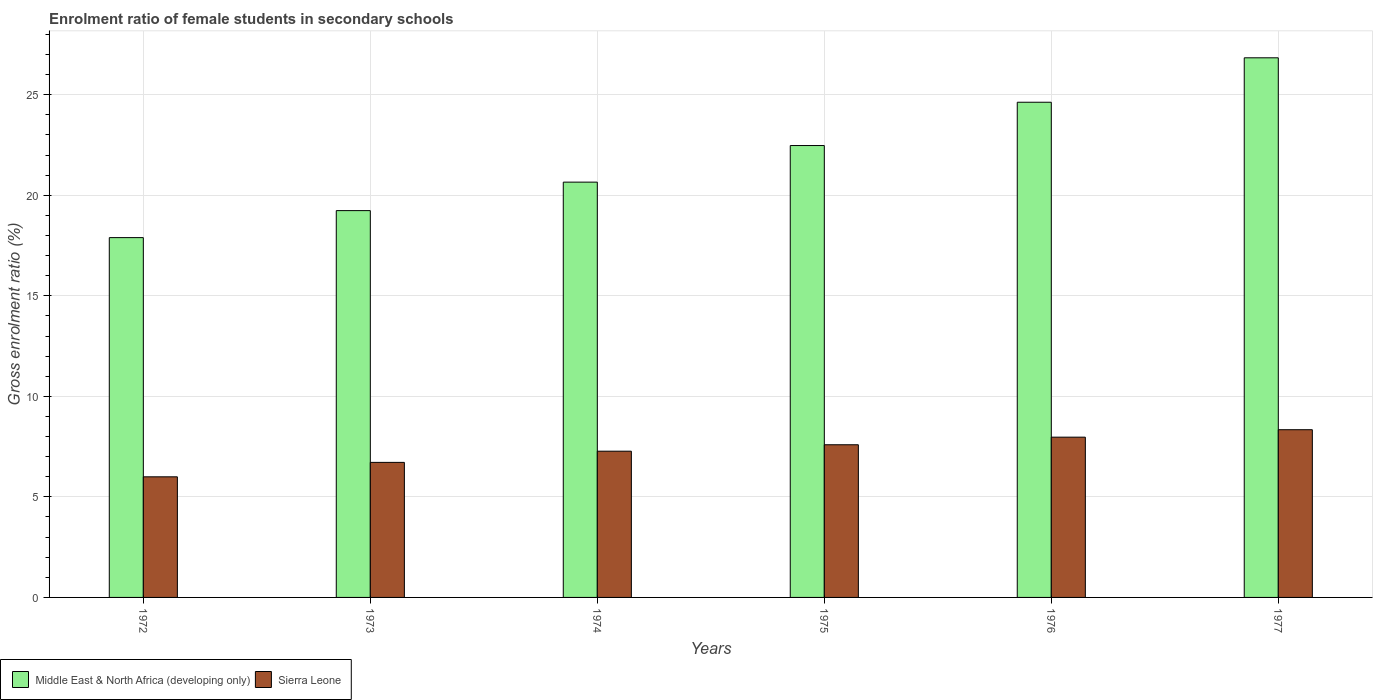How many different coloured bars are there?
Give a very brief answer. 2. How many groups of bars are there?
Your response must be concise. 6. How many bars are there on the 1st tick from the left?
Your response must be concise. 2. What is the label of the 1st group of bars from the left?
Make the answer very short. 1972. In how many cases, is the number of bars for a given year not equal to the number of legend labels?
Keep it short and to the point. 0. What is the enrolment ratio of female students in secondary schools in Middle East & North Africa (developing only) in 1975?
Provide a short and direct response. 22.47. Across all years, what is the maximum enrolment ratio of female students in secondary schools in Middle East & North Africa (developing only)?
Your response must be concise. 26.83. Across all years, what is the minimum enrolment ratio of female students in secondary schools in Sierra Leone?
Provide a succinct answer. 6. What is the total enrolment ratio of female students in secondary schools in Sierra Leone in the graph?
Give a very brief answer. 43.89. What is the difference between the enrolment ratio of female students in secondary schools in Middle East & North Africa (developing only) in 1974 and that in 1977?
Give a very brief answer. -6.18. What is the difference between the enrolment ratio of female students in secondary schools in Sierra Leone in 1977 and the enrolment ratio of female students in secondary schools in Middle East & North Africa (developing only) in 1976?
Your answer should be compact. -16.28. What is the average enrolment ratio of female students in secondary schools in Middle East & North Africa (developing only) per year?
Provide a short and direct response. 21.95. In the year 1974, what is the difference between the enrolment ratio of female students in secondary schools in Middle East & North Africa (developing only) and enrolment ratio of female students in secondary schools in Sierra Leone?
Provide a short and direct response. 13.38. What is the ratio of the enrolment ratio of female students in secondary schools in Middle East & North Africa (developing only) in 1974 to that in 1975?
Provide a short and direct response. 0.92. Is the enrolment ratio of female students in secondary schools in Sierra Leone in 1972 less than that in 1977?
Offer a terse response. Yes. Is the difference between the enrolment ratio of female students in secondary schools in Middle East & North Africa (developing only) in 1973 and 1977 greater than the difference between the enrolment ratio of female students in secondary schools in Sierra Leone in 1973 and 1977?
Provide a succinct answer. No. What is the difference between the highest and the second highest enrolment ratio of female students in secondary schools in Sierra Leone?
Provide a succinct answer. 0.37. What is the difference between the highest and the lowest enrolment ratio of female students in secondary schools in Sierra Leone?
Provide a short and direct response. 2.34. Is the sum of the enrolment ratio of female students in secondary schools in Sierra Leone in 1972 and 1975 greater than the maximum enrolment ratio of female students in secondary schools in Middle East & North Africa (developing only) across all years?
Make the answer very short. No. What does the 2nd bar from the left in 1975 represents?
Your answer should be very brief. Sierra Leone. What does the 2nd bar from the right in 1972 represents?
Your answer should be very brief. Middle East & North Africa (developing only). How many bars are there?
Your response must be concise. 12. Are all the bars in the graph horizontal?
Make the answer very short. No. Does the graph contain any zero values?
Make the answer very short. No. Where does the legend appear in the graph?
Give a very brief answer. Bottom left. What is the title of the graph?
Your response must be concise. Enrolment ratio of female students in secondary schools. Does "Uruguay" appear as one of the legend labels in the graph?
Give a very brief answer. No. What is the label or title of the X-axis?
Your answer should be very brief. Years. What is the Gross enrolment ratio (%) of Middle East & North Africa (developing only) in 1972?
Offer a terse response. 17.89. What is the Gross enrolment ratio (%) in Sierra Leone in 1972?
Give a very brief answer. 6. What is the Gross enrolment ratio (%) of Middle East & North Africa (developing only) in 1973?
Give a very brief answer. 19.24. What is the Gross enrolment ratio (%) in Sierra Leone in 1973?
Offer a very short reply. 6.72. What is the Gross enrolment ratio (%) of Middle East & North Africa (developing only) in 1974?
Your response must be concise. 20.65. What is the Gross enrolment ratio (%) of Sierra Leone in 1974?
Your answer should be very brief. 7.27. What is the Gross enrolment ratio (%) of Middle East & North Africa (developing only) in 1975?
Offer a very short reply. 22.47. What is the Gross enrolment ratio (%) of Sierra Leone in 1975?
Offer a terse response. 7.59. What is the Gross enrolment ratio (%) of Middle East & North Africa (developing only) in 1976?
Your answer should be compact. 24.62. What is the Gross enrolment ratio (%) of Sierra Leone in 1976?
Keep it short and to the point. 7.97. What is the Gross enrolment ratio (%) of Middle East & North Africa (developing only) in 1977?
Make the answer very short. 26.83. What is the Gross enrolment ratio (%) of Sierra Leone in 1977?
Provide a succinct answer. 8.34. Across all years, what is the maximum Gross enrolment ratio (%) of Middle East & North Africa (developing only)?
Provide a short and direct response. 26.83. Across all years, what is the maximum Gross enrolment ratio (%) in Sierra Leone?
Give a very brief answer. 8.34. Across all years, what is the minimum Gross enrolment ratio (%) of Middle East & North Africa (developing only)?
Provide a short and direct response. 17.89. Across all years, what is the minimum Gross enrolment ratio (%) of Sierra Leone?
Offer a terse response. 6. What is the total Gross enrolment ratio (%) of Middle East & North Africa (developing only) in the graph?
Your answer should be compact. 131.71. What is the total Gross enrolment ratio (%) in Sierra Leone in the graph?
Your answer should be compact. 43.89. What is the difference between the Gross enrolment ratio (%) of Middle East & North Africa (developing only) in 1972 and that in 1973?
Offer a very short reply. -1.34. What is the difference between the Gross enrolment ratio (%) of Sierra Leone in 1972 and that in 1973?
Offer a very short reply. -0.72. What is the difference between the Gross enrolment ratio (%) in Middle East & North Africa (developing only) in 1972 and that in 1974?
Ensure brevity in your answer.  -2.76. What is the difference between the Gross enrolment ratio (%) of Sierra Leone in 1972 and that in 1974?
Provide a short and direct response. -1.27. What is the difference between the Gross enrolment ratio (%) in Middle East & North Africa (developing only) in 1972 and that in 1975?
Give a very brief answer. -4.58. What is the difference between the Gross enrolment ratio (%) in Sierra Leone in 1972 and that in 1975?
Your response must be concise. -1.59. What is the difference between the Gross enrolment ratio (%) in Middle East & North Africa (developing only) in 1972 and that in 1976?
Ensure brevity in your answer.  -6.73. What is the difference between the Gross enrolment ratio (%) in Sierra Leone in 1972 and that in 1976?
Provide a succinct answer. -1.97. What is the difference between the Gross enrolment ratio (%) in Middle East & North Africa (developing only) in 1972 and that in 1977?
Make the answer very short. -8.94. What is the difference between the Gross enrolment ratio (%) of Sierra Leone in 1972 and that in 1977?
Your answer should be very brief. -2.34. What is the difference between the Gross enrolment ratio (%) of Middle East & North Africa (developing only) in 1973 and that in 1974?
Offer a terse response. -1.42. What is the difference between the Gross enrolment ratio (%) of Sierra Leone in 1973 and that in 1974?
Your response must be concise. -0.56. What is the difference between the Gross enrolment ratio (%) in Middle East & North Africa (developing only) in 1973 and that in 1975?
Make the answer very short. -3.24. What is the difference between the Gross enrolment ratio (%) of Sierra Leone in 1973 and that in 1975?
Ensure brevity in your answer.  -0.88. What is the difference between the Gross enrolment ratio (%) in Middle East & North Africa (developing only) in 1973 and that in 1976?
Provide a succinct answer. -5.39. What is the difference between the Gross enrolment ratio (%) in Sierra Leone in 1973 and that in 1976?
Make the answer very short. -1.25. What is the difference between the Gross enrolment ratio (%) in Middle East & North Africa (developing only) in 1973 and that in 1977?
Offer a terse response. -7.6. What is the difference between the Gross enrolment ratio (%) of Sierra Leone in 1973 and that in 1977?
Offer a terse response. -1.62. What is the difference between the Gross enrolment ratio (%) of Middle East & North Africa (developing only) in 1974 and that in 1975?
Keep it short and to the point. -1.82. What is the difference between the Gross enrolment ratio (%) of Sierra Leone in 1974 and that in 1975?
Ensure brevity in your answer.  -0.32. What is the difference between the Gross enrolment ratio (%) of Middle East & North Africa (developing only) in 1974 and that in 1976?
Your answer should be compact. -3.97. What is the difference between the Gross enrolment ratio (%) of Sierra Leone in 1974 and that in 1976?
Your answer should be very brief. -0.7. What is the difference between the Gross enrolment ratio (%) in Middle East & North Africa (developing only) in 1974 and that in 1977?
Make the answer very short. -6.18. What is the difference between the Gross enrolment ratio (%) in Sierra Leone in 1974 and that in 1977?
Your response must be concise. -1.07. What is the difference between the Gross enrolment ratio (%) of Middle East & North Africa (developing only) in 1975 and that in 1976?
Provide a short and direct response. -2.15. What is the difference between the Gross enrolment ratio (%) in Sierra Leone in 1975 and that in 1976?
Give a very brief answer. -0.38. What is the difference between the Gross enrolment ratio (%) in Middle East & North Africa (developing only) in 1975 and that in 1977?
Give a very brief answer. -4.36. What is the difference between the Gross enrolment ratio (%) of Sierra Leone in 1975 and that in 1977?
Your answer should be compact. -0.75. What is the difference between the Gross enrolment ratio (%) of Middle East & North Africa (developing only) in 1976 and that in 1977?
Give a very brief answer. -2.21. What is the difference between the Gross enrolment ratio (%) in Sierra Leone in 1976 and that in 1977?
Offer a very short reply. -0.37. What is the difference between the Gross enrolment ratio (%) in Middle East & North Africa (developing only) in 1972 and the Gross enrolment ratio (%) in Sierra Leone in 1973?
Provide a succinct answer. 11.18. What is the difference between the Gross enrolment ratio (%) of Middle East & North Africa (developing only) in 1972 and the Gross enrolment ratio (%) of Sierra Leone in 1974?
Give a very brief answer. 10.62. What is the difference between the Gross enrolment ratio (%) in Middle East & North Africa (developing only) in 1972 and the Gross enrolment ratio (%) in Sierra Leone in 1975?
Your response must be concise. 10.3. What is the difference between the Gross enrolment ratio (%) in Middle East & North Africa (developing only) in 1972 and the Gross enrolment ratio (%) in Sierra Leone in 1976?
Provide a succinct answer. 9.92. What is the difference between the Gross enrolment ratio (%) in Middle East & North Africa (developing only) in 1972 and the Gross enrolment ratio (%) in Sierra Leone in 1977?
Provide a succinct answer. 9.55. What is the difference between the Gross enrolment ratio (%) of Middle East & North Africa (developing only) in 1973 and the Gross enrolment ratio (%) of Sierra Leone in 1974?
Your answer should be compact. 11.96. What is the difference between the Gross enrolment ratio (%) in Middle East & North Africa (developing only) in 1973 and the Gross enrolment ratio (%) in Sierra Leone in 1975?
Give a very brief answer. 11.64. What is the difference between the Gross enrolment ratio (%) of Middle East & North Africa (developing only) in 1973 and the Gross enrolment ratio (%) of Sierra Leone in 1976?
Your answer should be very brief. 11.27. What is the difference between the Gross enrolment ratio (%) in Middle East & North Africa (developing only) in 1973 and the Gross enrolment ratio (%) in Sierra Leone in 1977?
Your response must be concise. 10.9. What is the difference between the Gross enrolment ratio (%) in Middle East & North Africa (developing only) in 1974 and the Gross enrolment ratio (%) in Sierra Leone in 1975?
Provide a short and direct response. 13.06. What is the difference between the Gross enrolment ratio (%) of Middle East & North Africa (developing only) in 1974 and the Gross enrolment ratio (%) of Sierra Leone in 1976?
Your response must be concise. 12.68. What is the difference between the Gross enrolment ratio (%) of Middle East & North Africa (developing only) in 1974 and the Gross enrolment ratio (%) of Sierra Leone in 1977?
Your response must be concise. 12.31. What is the difference between the Gross enrolment ratio (%) of Middle East & North Africa (developing only) in 1975 and the Gross enrolment ratio (%) of Sierra Leone in 1976?
Make the answer very short. 14.5. What is the difference between the Gross enrolment ratio (%) of Middle East & North Africa (developing only) in 1975 and the Gross enrolment ratio (%) of Sierra Leone in 1977?
Your answer should be very brief. 14.13. What is the difference between the Gross enrolment ratio (%) of Middle East & North Africa (developing only) in 1976 and the Gross enrolment ratio (%) of Sierra Leone in 1977?
Your answer should be compact. 16.28. What is the average Gross enrolment ratio (%) in Middle East & North Africa (developing only) per year?
Offer a very short reply. 21.95. What is the average Gross enrolment ratio (%) in Sierra Leone per year?
Your answer should be very brief. 7.31. In the year 1972, what is the difference between the Gross enrolment ratio (%) in Middle East & North Africa (developing only) and Gross enrolment ratio (%) in Sierra Leone?
Provide a short and direct response. 11.89. In the year 1973, what is the difference between the Gross enrolment ratio (%) in Middle East & North Africa (developing only) and Gross enrolment ratio (%) in Sierra Leone?
Offer a very short reply. 12.52. In the year 1974, what is the difference between the Gross enrolment ratio (%) in Middle East & North Africa (developing only) and Gross enrolment ratio (%) in Sierra Leone?
Your answer should be very brief. 13.38. In the year 1975, what is the difference between the Gross enrolment ratio (%) in Middle East & North Africa (developing only) and Gross enrolment ratio (%) in Sierra Leone?
Give a very brief answer. 14.88. In the year 1976, what is the difference between the Gross enrolment ratio (%) of Middle East & North Africa (developing only) and Gross enrolment ratio (%) of Sierra Leone?
Your response must be concise. 16.66. In the year 1977, what is the difference between the Gross enrolment ratio (%) of Middle East & North Africa (developing only) and Gross enrolment ratio (%) of Sierra Leone?
Your answer should be compact. 18.49. What is the ratio of the Gross enrolment ratio (%) in Middle East & North Africa (developing only) in 1972 to that in 1973?
Provide a short and direct response. 0.93. What is the ratio of the Gross enrolment ratio (%) of Sierra Leone in 1972 to that in 1973?
Your response must be concise. 0.89. What is the ratio of the Gross enrolment ratio (%) of Middle East & North Africa (developing only) in 1972 to that in 1974?
Make the answer very short. 0.87. What is the ratio of the Gross enrolment ratio (%) in Sierra Leone in 1972 to that in 1974?
Provide a short and direct response. 0.82. What is the ratio of the Gross enrolment ratio (%) in Middle East & North Africa (developing only) in 1972 to that in 1975?
Ensure brevity in your answer.  0.8. What is the ratio of the Gross enrolment ratio (%) in Sierra Leone in 1972 to that in 1975?
Keep it short and to the point. 0.79. What is the ratio of the Gross enrolment ratio (%) in Middle East & North Africa (developing only) in 1972 to that in 1976?
Offer a terse response. 0.73. What is the ratio of the Gross enrolment ratio (%) of Sierra Leone in 1972 to that in 1976?
Keep it short and to the point. 0.75. What is the ratio of the Gross enrolment ratio (%) in Middle East & North Africa (developing only) in 1972 to that in 1977?
Offer a terse response. 0.67. What is the ratio of the Gross enrolment ratio (%) of Sierra Leone in 1972 to that in 1977?
Your answer should be compact. 0.72. What is the ratio of the Gross enrolment ratio (%) of Middle East & North Africa (developing only) in 1973 to that in 1974?
Your answer should be compact. 0.93. What is the ratio of the Gross enrolment ratio (%) in Sierra Leone in 1973 to that in 1974?
Keep it short and to the point. 0.92. What is the ratio of the Gross enrolment ratio (%) of Middle East & North Africa (developing only) in 1973 to that in 1975?
Provide a short and direct response. 0.86. What is the ratio of the Gross enrolment ratio (%) of Sierra Leone in 1973 to that in 1975?
Offer a terse response. 0.88. What is the ratio of the Gross enrolment ratio (%) in Middle East & North Africa (developing only) in 1973 to that in 1976?
Make the answer very short. 0.78. What is the ratio of the Gross enrolment ratio (%) in Sierra Leone in 1973 to that in 1976?
Offer a terse response. 0.84. What is the ratio of the Gross enrolment ratio (%) in Middle East & North Africa (developing only) in 1973 to that in 1977?
Your response must be concise. 0.72. What is the ratio of the Gross enrolment ratio (%) in Sierra Leone in 1973 to that in 1977?
Your answer should be very brief. 0.81. What is the ratio of the Gross enrolment ratio (%) in Middle East & North Africa (developing only) in 1974 to that in 1975?
Ensure brevity in your answer.  0.92. What is the ratio of the Gross enrolment ratio (%) of Sierra Leone in 1974 to that in 1975?
Keep it short and to the point. 0.96. What is the ratio of the Gross enrolment ratio (%) in Middle East & North Africa (developing only) in 1974 to that in 1976?
Give a very brief answer. 0.84. What is the ratio of the Gross enrolment ratio (%) of Sierra Leone in 1974 to that in 1976?
Give a very brief answer. 0.91. What is the ratio of the Gross enrolment ratio (%) in Middle East & North Africa (developing only) in 1974 to that in 1977?
Offer a very short reply. 0.77. What is the ratio of the Gross enrolment ratio (%) in Sierra Leone in 1974 to that in 1977?
Your answer should be compact. 0.87. What is the ratio of the Gross enrolment ratio (%) of Middle East & North Africa (developing only) in 1975 to that in 1976?
Your response must be concise. 0.91. What is the ratio of the Gross enrolment ratio (%) in Sierra Leone in 1975 to that in 1976?
Give a very brief answer. 0.95. What is the ratio of the Gross enrolment ratio (%) of Middle East & North Africa (developing only) in 1975 to that in 1977?
Offer a very short reply. 0.84. What is the ratio of the Gross enrolment ratio (%) of Sierra Leone in 1975 to that in 1977?
Provide a succinct answer. 0.91. What is the ratio of the Gross enrolment ratio (%) of Middle East & North Africa (developing only) in 1976 to that in 1977?
Offer a very short reply. 0.92. What is the ratio of the Gross enrolment ratio (%) in Sierra Leone in 1976 to that in 1977?
Your answer should be compact. 0.96. What is the difference between the highest and the second highest Gross enrolment ratio (%) of Middle East & North Africa (developing only)?
Make the answer very short. 2.21. What is the difference between the highest and the second highest Gross enrolment ratio (%) in Sierra Leone?
Your answer should be compact. 0.37. What is the difference between the highest and the lowest Gross enrolment ratio (%) in Middle East & North Africa (developing only)?
Give a very brief answer. 8.94. What is the difference between the highest and the lowest Gross enrolment ratio (%) of Sierra Leone?
Offer a terse response. 2.34. 